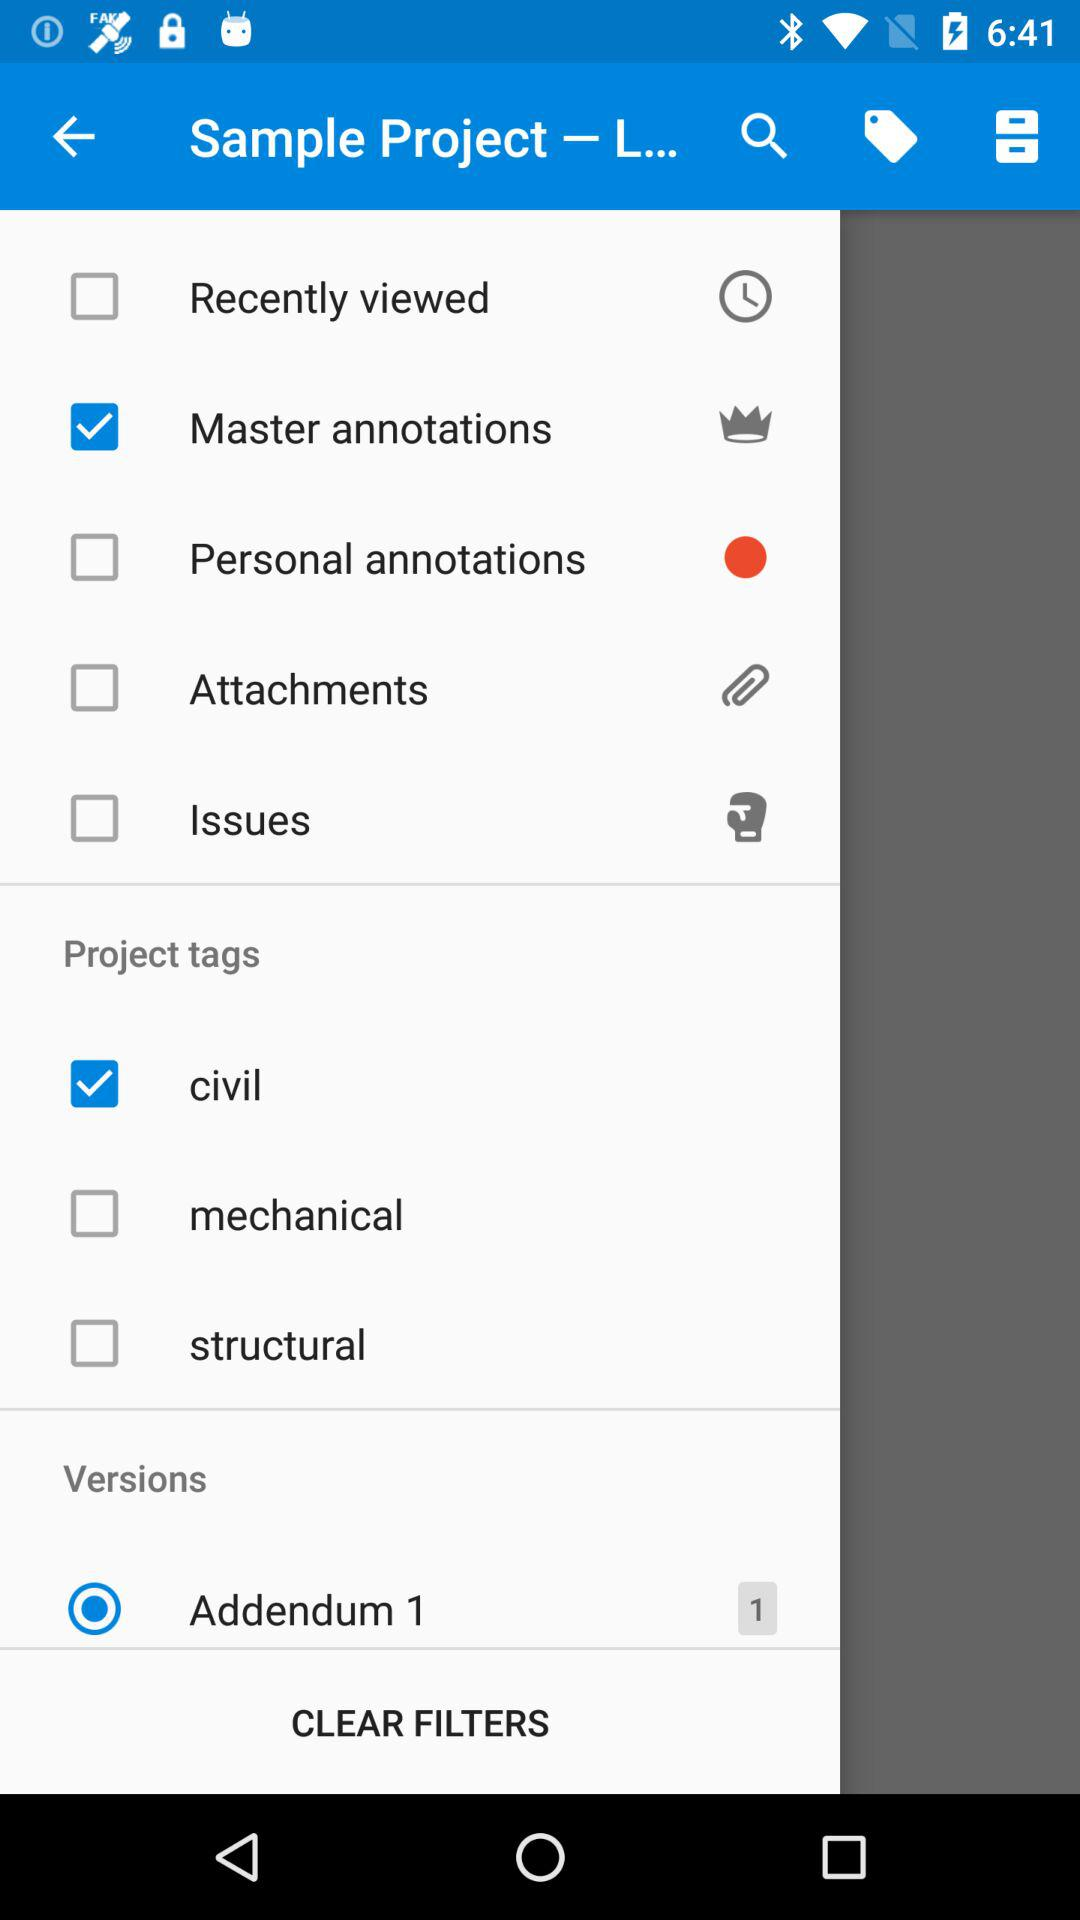What project tags are not selected? The project tags which are not selected are "mechanical" and "structural". 